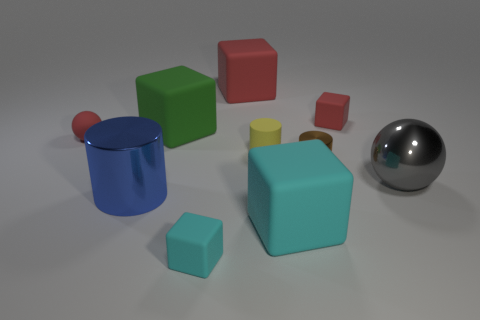What is the material of the big cyan thing?
Keep it short and to the point. Rubber. How many other big cylinders have the same material as the yellow cylinder?
Make the answer very short. 0. What number of rubber objects are either blocks or tiny yellow cylinders?
Offer a terse response. 6. Does the tiny red thing that is on the right side of the large green matte object have the same shape as the big metallic thing right of the brown cylinder?
Make the answer very short. No. What is the color of the thing that is to the left of the big green rubber block and in front of the small red matte ball?
Ensure brevity in your answer.  Blue. Is the size of the object on the left side of the large cylinder the same as the metallic cylinder to the right of the large blue thing?
Make the answer very short. Yes. What number of balls are the same color as the tiny shiny cylinder?
Offer a very short reply. 0. What number of tiny objects are either cyan cubes or cylinders?
Ensure brevity in your answer.  3. Do the large block right of the yellow rubber cylinder and the big gray sphere have the same material?
Make the answer very short. No. What color is the small block in front of the tiny metallic thing?
Your response must be concise. Cyan. 